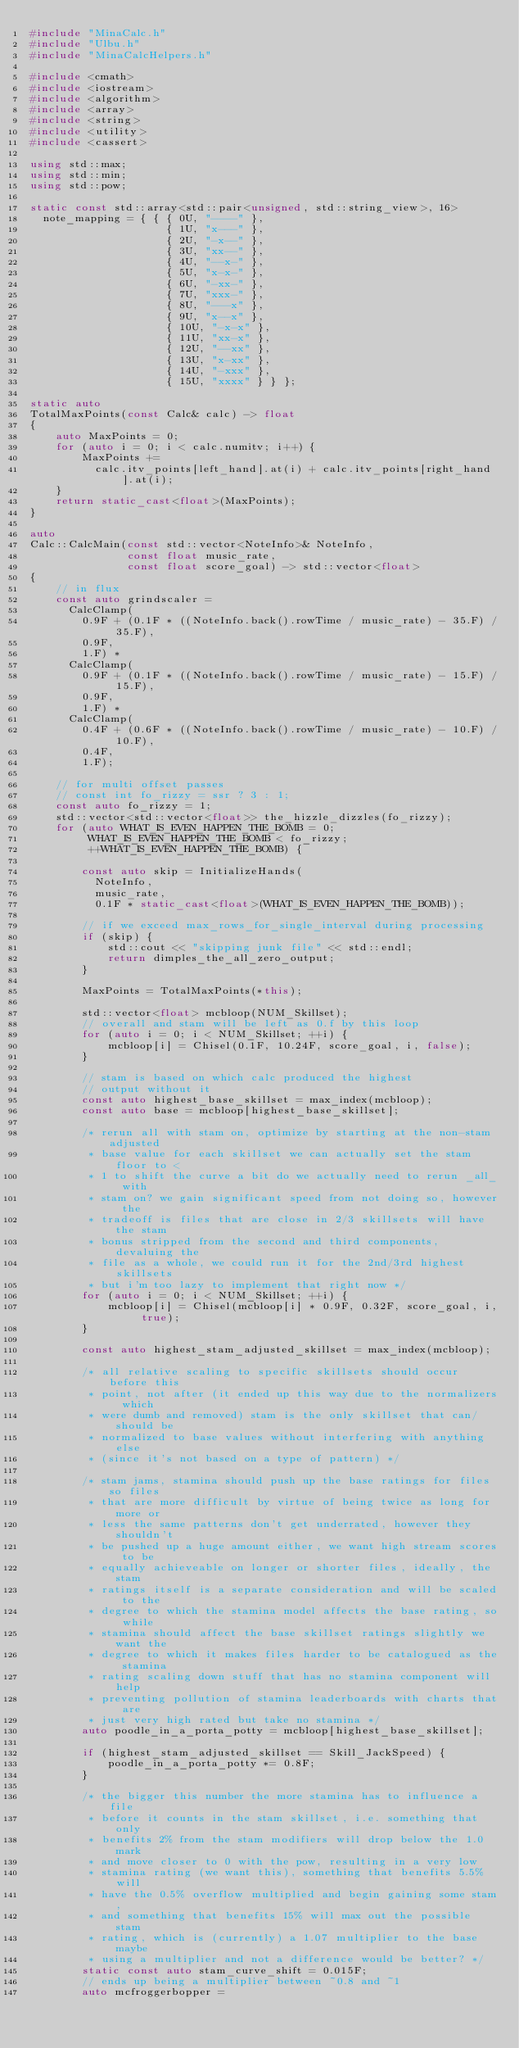<code> <loc_0><loc_0><loc_500><loc_500><_C++_>#include "MinaCalc.h"
#include "Ulbu.h"
#include "MinaCalcHelpers.h"

#include <cmath>
#include <iostream>
#include <algorithm>
#include <array>
#include <string>
#include <utility>
#include <cassert>

using std::max;
using std::min;
using std::pow;

static const std::array<std::pair<unsigned, std::string_view>, 16>
  note_mapping = { { { 0U, "----" },
					 { 1U, "x---" },
					 { 2U, "-x--" },
					 { 3U, "xx--" },
					 { 4U, "--x-" },
					 { 5U, "x-x-" },
					 { 6U, "-xx-" },
					 { 7U, "xxx-" },
					 { 8U, "---x" },
					 { 9U, "x--x" },
					 { 10U, "-x-x" },
					 { 11U, "xx-x" },
					 { 12U, "--xx" },
					 { 13U, "x-xx" },
					 { 14U, "-xxx" },
					 { 15U, "xxxx" } } };

static auto
TotalMaxPoints(const Calc& calc) -> float
{
	auto MaxPoints = 0;
	for (auto i = 0; i < calc.numitv; i++) {
		MaxPoints +=
		  calc.itv_points[left_hand].at(i) + calc.itv_points[right_hand].at(i);
	}
	return static_cast<float>(MaxPoints);
}

auto
Calc::CalcMain(const std::vector<NoteInfo>& NoteInfo,
			   const float music_rate,
			   const float score_goal) -> std::vector<float>
{
	// in flux
	const auto grindscaler =
	  CalcClamp(
		0.9F + (0.1F * ((NoteInfo.back().rowTime / music_rate) - 35.F) / 35.F),
		0.9F,
		1.F) *
	  CalcClamp(
		0.9F + (0.1F * ((NoteInfo.back().rowTime / music_rate) - 15.F) / 15.F),
		0.9F,
		1.F) *
	  CalcClamp(
		0.4F + (0.6F * ((NoteInfo.back().rowTime / music_rate) - 10.F) / 10.F),
		0.4F,
		1.F);

	// for multi offset passes
	// const int fo_rizzy = ssr ? 3 : 1;
	const auto fo_rizzy = 1;
	std::vector<std::vector<float>> the_hizzle_dizzles(fo_rizzy);
	for (auto WHAT_IS_EVEN_HAPPEN_THE_BOMB = 0;
		 WHAT_IS_EVEN_HAPPEN_THE_BOMB < fo_rizzy;
		 ++WHAT_IS_EVEN_HAPPEN_THE_BOMB) {

		const auto skip = InitializeHands(
		  NoteInfo,
		  music_rate,
		  0.1F * static_cast<float>(WHAT_IS_EVEN_HAPPEN_THE_BOMB));

		// if we exceed max_rows_for_single_interval during processing
		if (skip) {
			std::cout << "skipping junk file" << std::endl;
			return dimples_the_all_zero_output;
		}

		MaxPoints = TotalMaxPoints(*this);

		std::vector<float> mcbloop(NUM_Skillset);
		// overall and stam will be left as 0.f by this loop
		for (auto i = 0; i < NUM_Skillset; ++i) {
			mcbloop[i] = Chisel(0.1F, 10.24F, score_goal, i, false);
		}

		// stam is based on which calc produced the highest
		// output without it
		const auto highest_base_skillset = max_index(mcbloop);
		const auto base = mcbloop[highest_base_skillset];

		/* rerun all with stam on, optimize by starting at the non-stam adjusted
		 * base value for each skillset we can actually set the stam floor to <
		 * 1 to shift the curve a bit do we actually need to rerun _all_ with
		 * stam on? we gain significant speed from not doing so, however the
		 * tradeoff is files that are close in 2/3 skillsets will have the stam
		 * bonus stripped from the second and third components, devaluing the
		 * file as a whole, we could run it for the 2nd/3rd highest skillsets
		 * but i'm too lazy to implement that right now */
		for (auto i = 0; i < NUM_Skillset; ++i) {
			mcbloop[i] = Chisel(mcbloop[i] * 0.9F, 0.32F, score_goal, i, true);
		}

		const auto highest_stam_adjusted_skillset = max_index(mcbloop);

		/* all relative scaling to specific skillsets should occur before this
		 * point, not after (it ended up this way due to the normalizers which
		 * were dumb and removed) stam is the only skillset that can/should be
		 * normalized to base values without interfering with anything else
		 * (since it's not based on a type of pattern) */

		/* stam jams, stamina should push up the base ratings for files so files
		 * that are more difficult by virtue of being twice as long for more or
		 * less the same patterns don't get underrated, however they shouldn't
		 * be pushed up a huge amount either, we want high stream scores to be
		 * equally achieveable on longer or shorter files, ideally, the stam
		 * ratings itself is a separate consideration and will be scaled to the
		 * degree to which the stamina model affects the base rating, so while
		 * stamina should affect the base skillset ratings slightly we want the
		 * degree to which it makes files harder to be catalogued as the stamina
		 * rating scaling down stuff that has no stamina component will help
		 * preventing pollution of stamina leaderboards with charts that are
		 * just very high rated but take no stamina */
		auto poodle_in_a_porta_potty = mcbloop[highest_base_skillset];

		if (highest_stam_adjusted_skillset == Skill_JackSpeed) {
			poodle_in_a_porta_potty *= 0.8F;
		}

		/* the bigger this number the more stamina has to influence a file
		 * before it counts in the stam skillset, i.e. something that only
		 * benefits 2% from the stam modifiers will drop below the 1.0 mark
		 * and move closer to 0 with the pow, resulting in a very low
		 * stamina rating (we want this), something that benefits 5.5% will
		 * have the 0.5% overflow multiplied and begin gaining some stam,
		 * and something that benefits 15% will max out the possible stam
		 * rating, which is (currently) a 1.07 multiplier to the base maybe
		 * using a multiplier and not a difference would be better? */
		static const auto stam_curve_shift = 0.015F;
		// ends up being a multiplier between ~0.8 and ~1
		auto mcfroggerbopper =</code> 